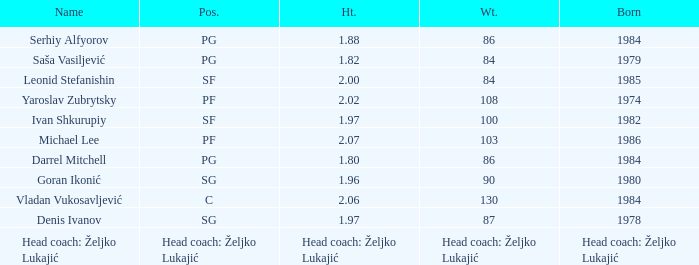What was the weight of Serhiy Alfyorov? 86.0. 